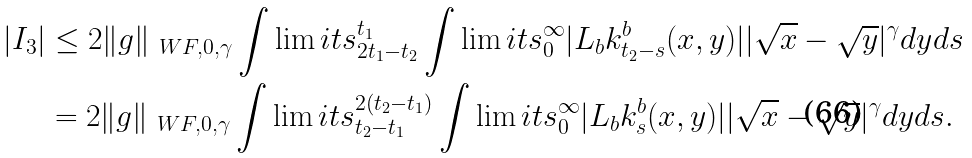Convert formula to latex. <formula><loc_0><loc_0><loc_500><loc_500>| I _ { 3 } | & \leq 2 \| g \| _ { \ W F , 0 , \gamma } \int \lim i t s _ { 2 t _ { 1 } - t _ { 2 } } ^ { t _ { 1 } } \int \lim i t s _ { 0 } ^ { \infty } | L _ { b } k ^ { b } _ { t _ { 2 } - s } ( x , y ) | | \sqrt { x } - \sqrt { y } | ^ { \gamma } d y d s \\ & = 2 \| g \| _ { \ W F , 0 , \gamma } \int \lim i t s _ { t _ { 2 } - t _ { 1 } } ^ { 2 ( t _ { 2 } - t _ { 1 } ) } \int \lim i t s _ { 0 } ^ { \infty } | L _ { b } k ^ { b } _ { s } ( x , y ) | | \sqrt { x } - \sqrt { y } | ^ { \gamma } d y d s .</formula> 